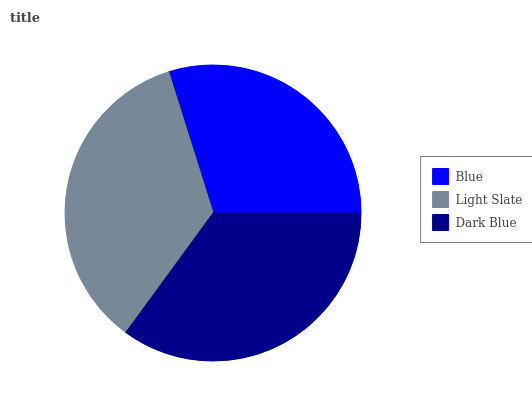Is Blue the minimum?
Answer yes or no. Yes. Is Light Slate the maximum?
Answer yes or no. Yes. Is Dark Blue the minimum?
Answer yes or no. No. Is Dark Blue the maximum?
Answer yes or no. No. Is Light Slate greater than Dark Blue?
Answer yes or no. Yes. Is Dark Blue less than Light Slate?
Answer yes or no. Yes. Is Dark Blue greater than Light Slate?
Answer yes or no. No. Is Light Slate less than Dark Blue?
Answer yes or no. No. Is Dark Blue the high median?
Answer yes or no. Yes. Is Dark Blue the low median?
Answer yes or no. Yes. Is Light Slate the high median?
Answer yes or no. No. Is Blue the low median?
Answer yes or no. No. 